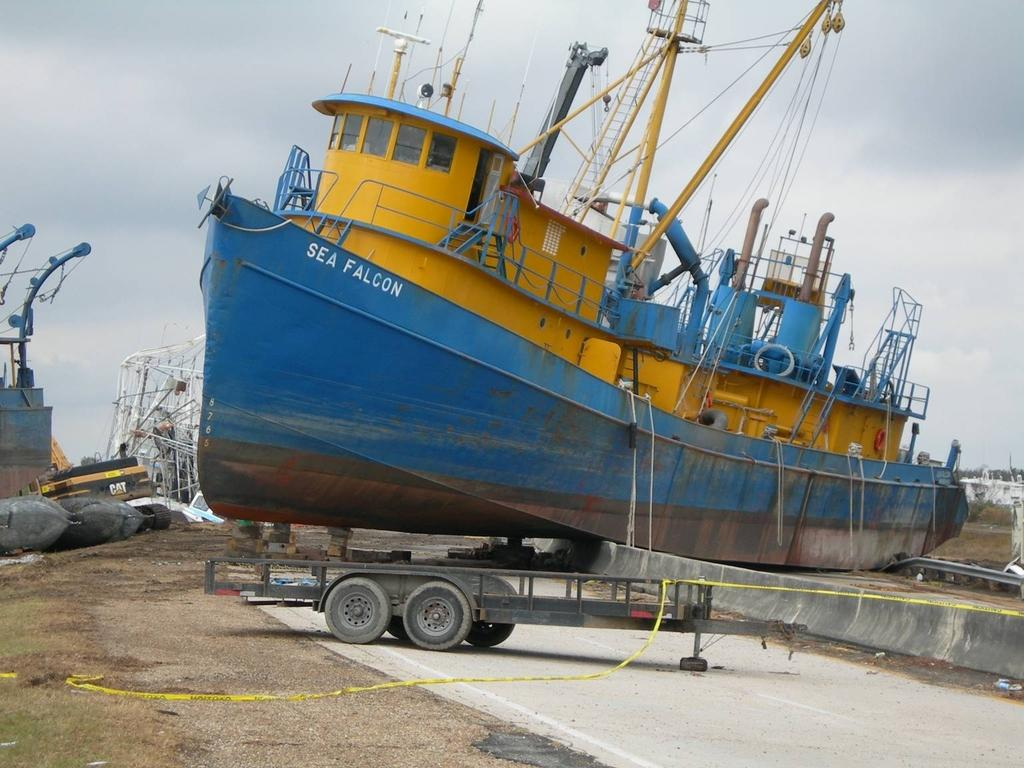<image>
Describe the image concisely. A yellow and blue ship that has the words sea falcon on the front. 